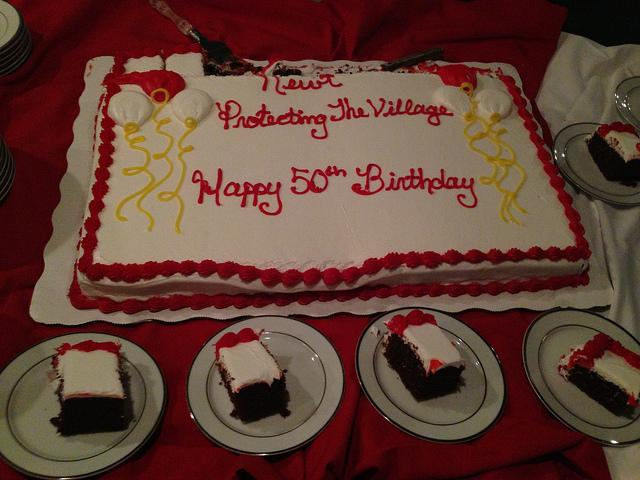The birthday boy has a name that refers to what kind of animal? newt 